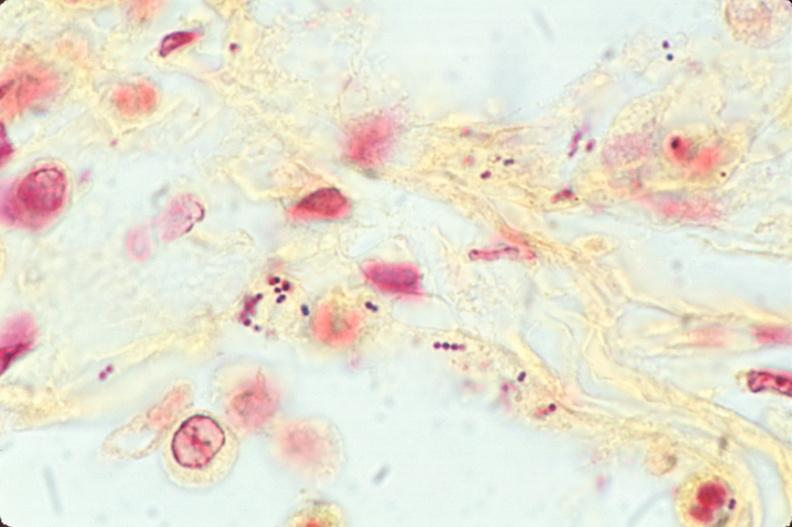do this image shows lung, bronchopneumonia, bacterial, tissue gram stain?
Answer the question using a single word or phrase. Yes 